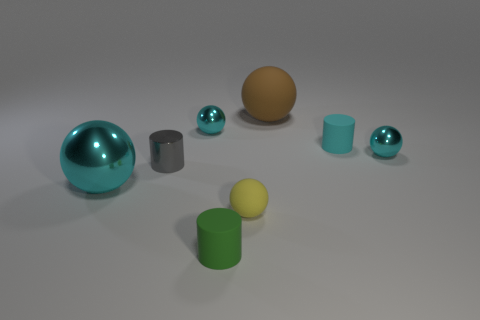How many cyan balls must be subtracted to get 1 cyan balls? 2 Subtract all brown matte spheres. How many spheres are left? 4 Add 1 tiny green objects. How many objects exist? 9 Subtract all gray cylinders. How many cylinders are left? 2 Subtract 1 balls. How many balls are left? 4 Subtract all cylinders. How many objects are left? 5 Subtract all yellow cylinders. Subtract all yellow blocks. How many cylinders are left? 3 Subtract all brown balls. How many cyan cylinders are left? 1 Subtract all tiny purple shiny objects. Subtract all large brown rubber objects. How many objects are left? 7 Add 4 big cyan shiny spheres. How many big cyan shiny spheres are left? 5 